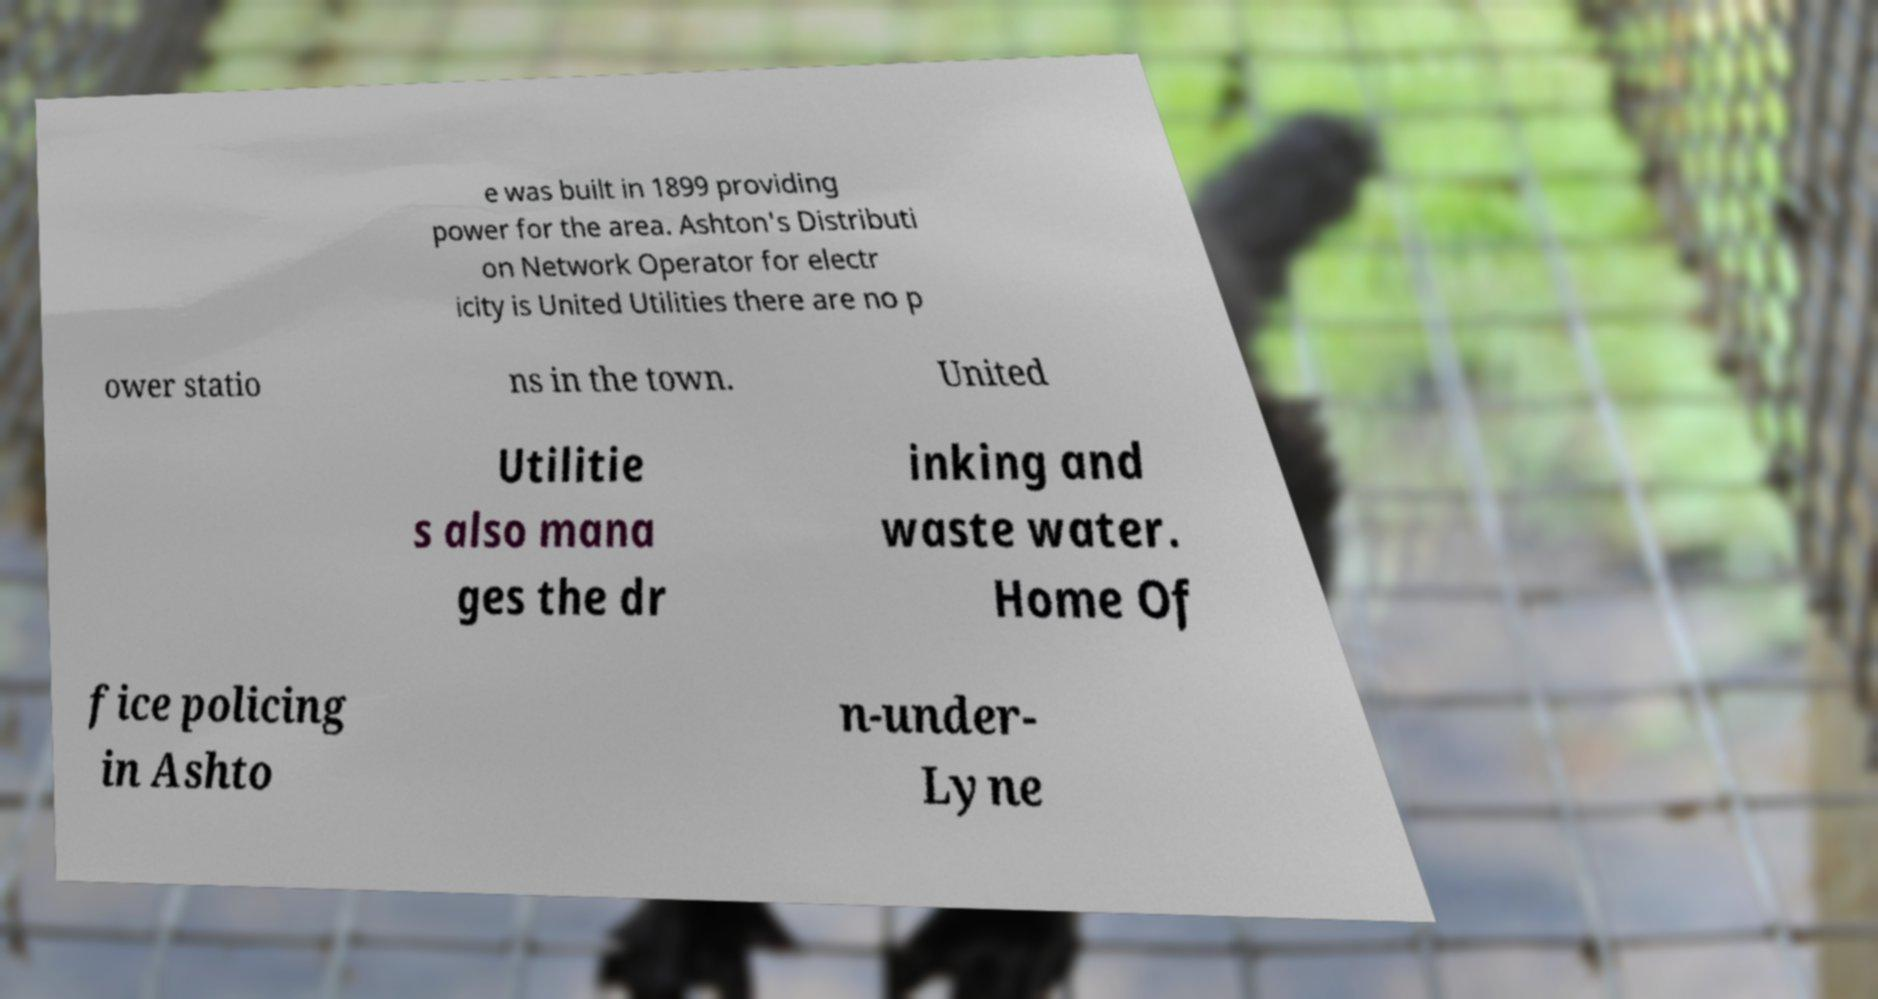Could you extract and type out the text from this image? e was built in 1899 providing power for the area. Ashton's Distributi on Network Operator for electr icity is United Utilities there are no p ower statio ns in the town. United Utilitie s also mana ges the dr inking and waste water. Home Of fice policing in Ashto n-under- Lyne 